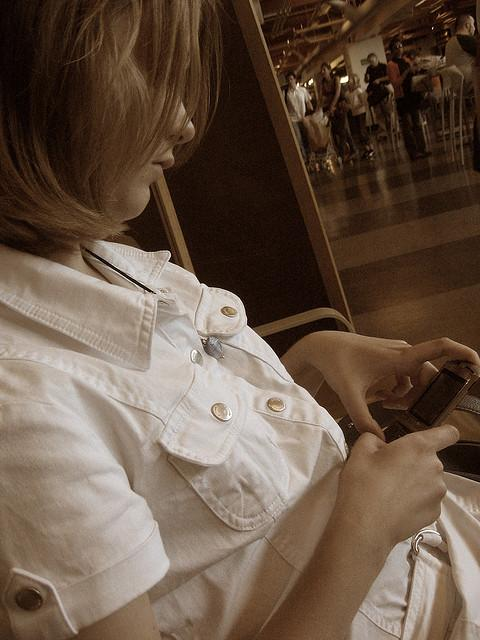What are the people lining up for? Please explain your reasoning. buying food. The atmosphere of this building with chairs and tables tells us it's probably a restaurant. a restaurant sells food. 